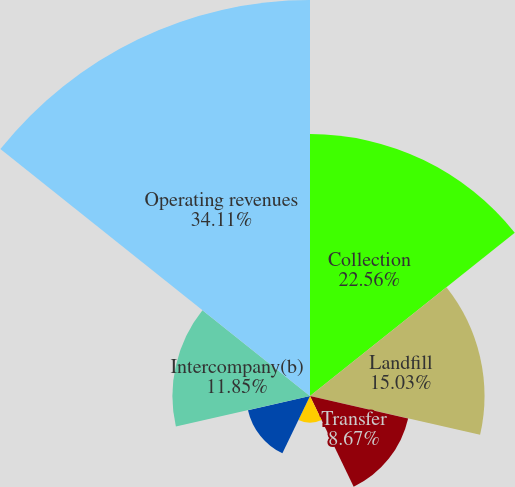Convert chart. <chart><loc_0><loc_0><loc_500><loc_500><pie_chart><fcel>Collection<fcel>Landfill<fcel>Transfer<fcel>Wheelabrator<fcel>Recycling and other(a)<fcel>Intercompany(b)<fcel>Operating revenues<nl><fcel>22.56%<fcel>15.03%<fcel>8.67%<fcel>2.3%<fcel>5.48%<fcel>11.85%<fcel>34.11%<nl></chart> 